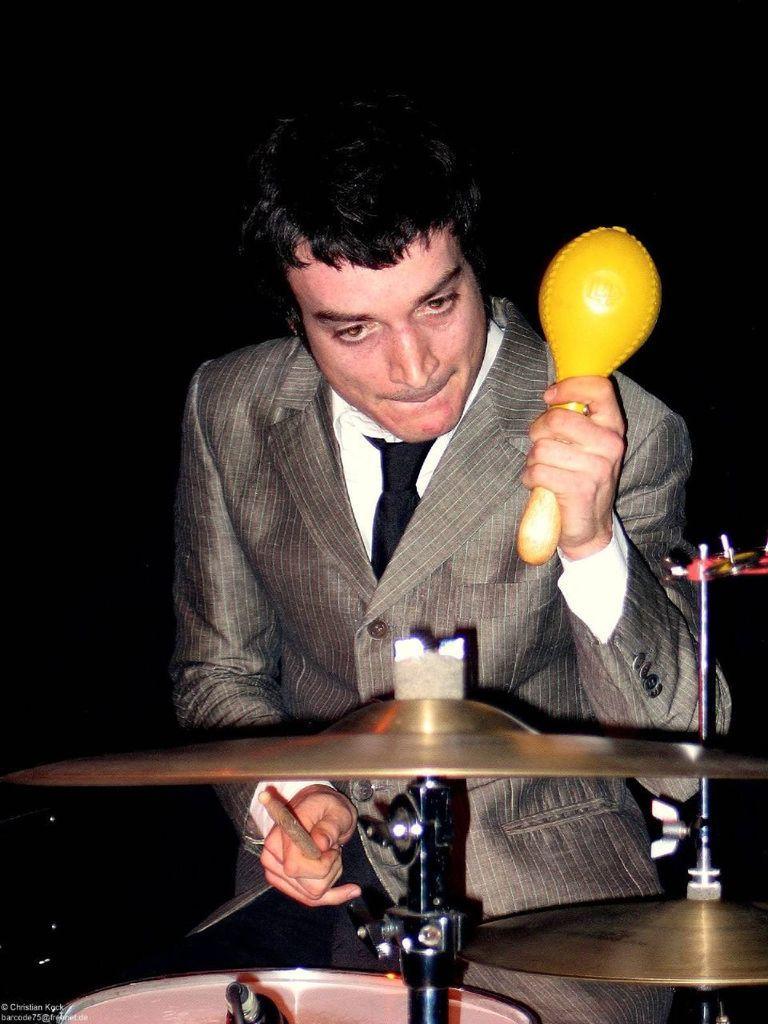How would you summarize this image in a sentence or two? In the image we can see there is a man who is standing and in front of him there is a drum set and he is playing it. 